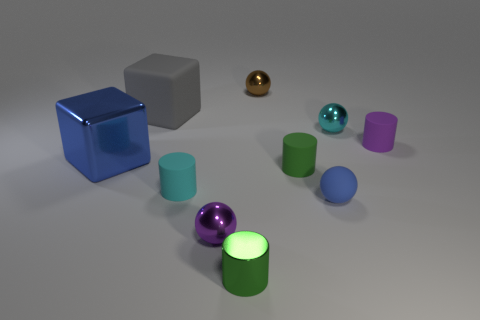Subtract all small purple balls. How many balls are left? 3 Subtract all spheres. How many objects are left? 6 Subtract all purple cylinders. How many cylinders are left? 3 Add 5 green shiny objects. How many green shiny objects are left? 6 Add 4 purple cylinders. How many purple cylinders exist? 5 Subtract 0 red cylinders. How many objects are left? 10 Subtract 4 cylinders. How many cylinders are left? 0 Subtract all blue cylinders. Subtract all brown spheres. How many cylinders are left? 4 Subtract all yellow cylinders. How many blue cubes are left? 1 Subtract all rubber cylinders. Subtract all big rubber cubes. How many objects are left? 6 